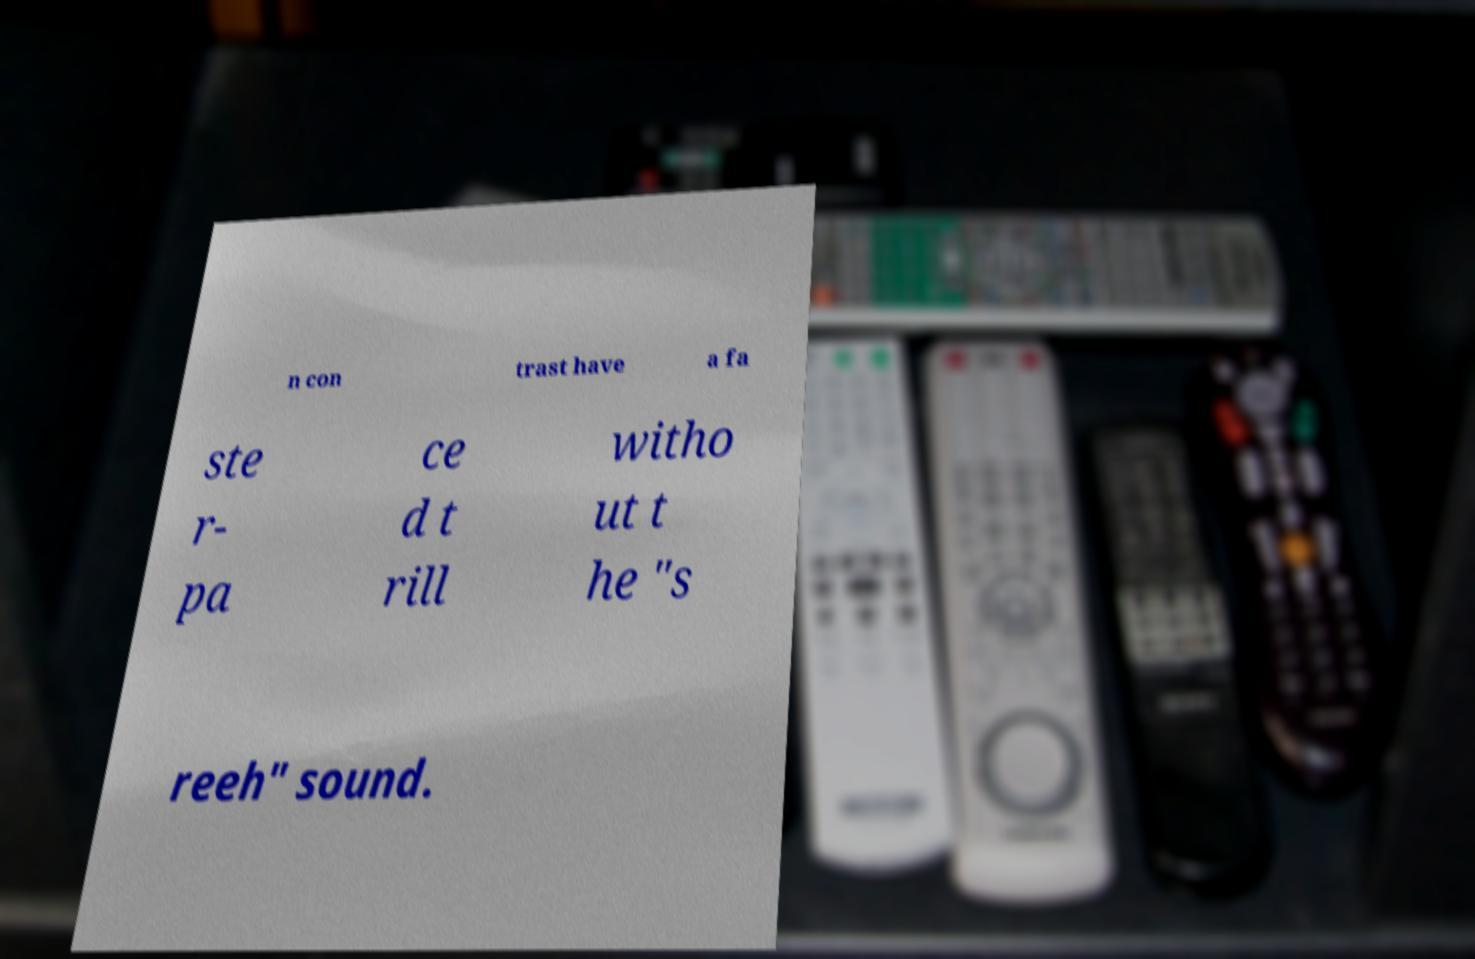For documentation purposes, I need the text within this image transcribed. Could you provide that? n con trast have a fa ste r- pa ce d t rill witho ut t he "s reeh" sound. 